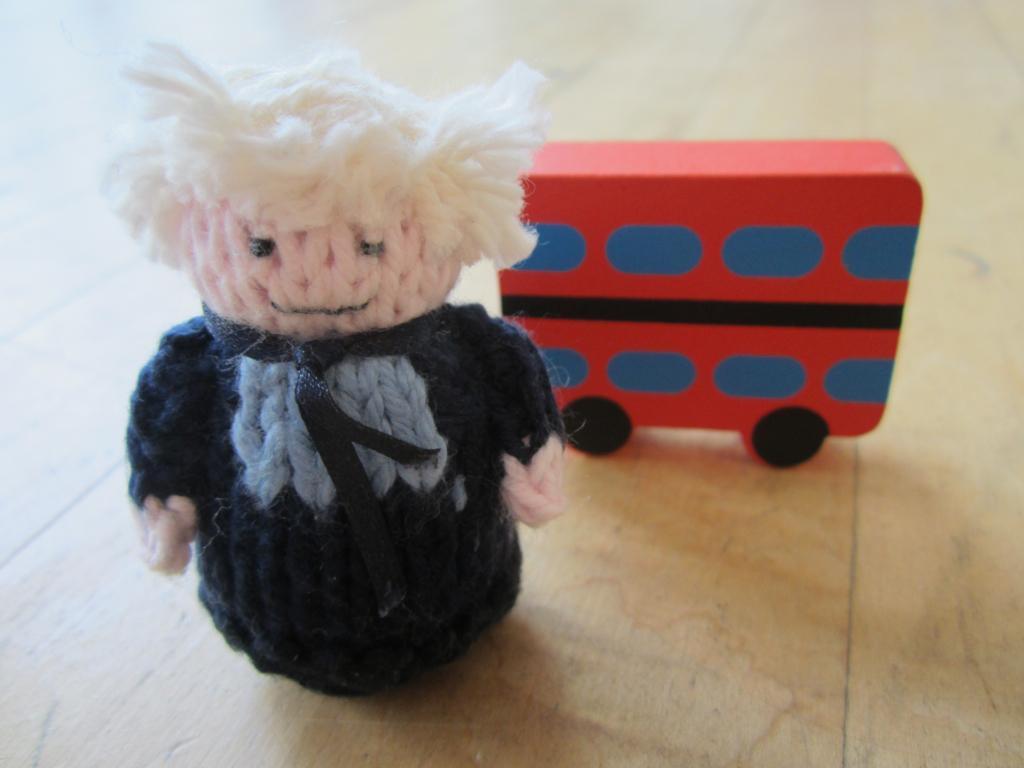Could you give a brief overview of what you see in this image? This image consists of toys. They are handmade. One looks like a person, another one looks like a bus. 